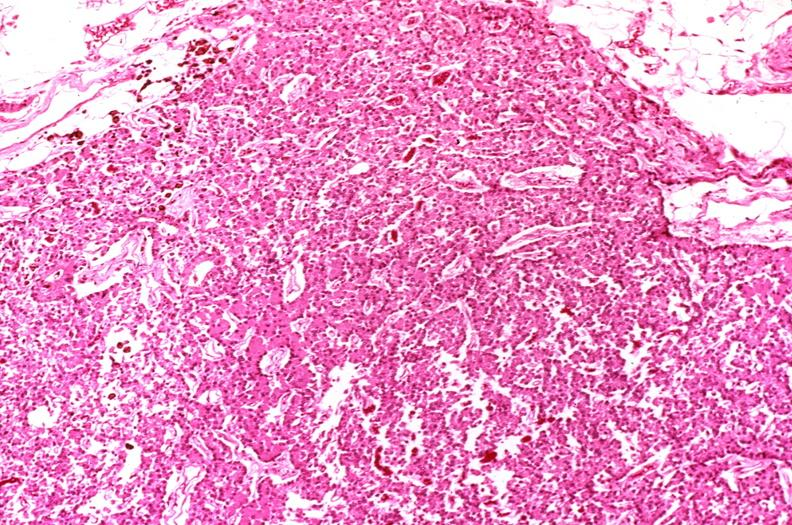s coronary artery anomalous origin left from pulmonary artery present?
Answer the question using a single word or phrase. No 